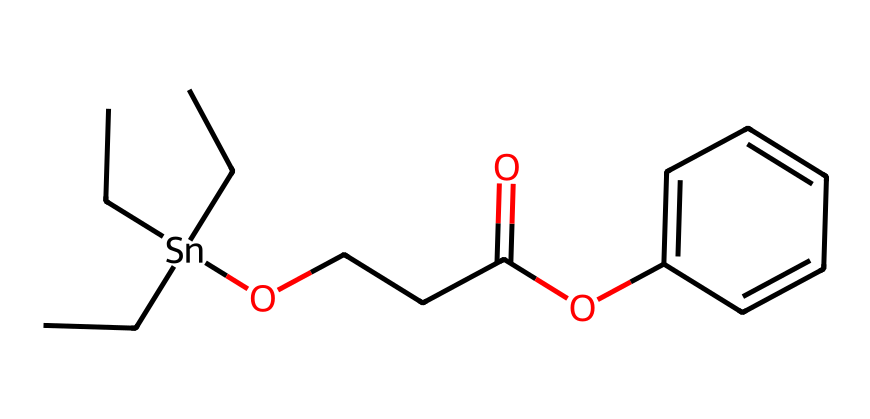What is the main metal present in this compound? The structure shows a tin atom connected to other carbon and oxygen atoms, which indicates that tin is the main metal component in this organometallic compound.
Answer: tin How many carbon atoms are present in this chemical? By counting the carbon atoms in the structure, including those in the alkyl groups and the aromatic ring, we find there are a total of 12 carbon atoms.
Answer: 12 What functional group is present in this compound that contributes to its weather resistance? The presence of an ester functional group (–COO–) in the chemical structure indicates that this compound can form protective layers, enhancing its weather resistance.
Answer: ester What is the connectivity of the tin atom in this structure? The tin atom (Sn) is coordinated to three carbon chains and one oxygen atom, forming a tetrahedral geometry where the atom is bonded to four different groups.
Answer: tetrahedral Which part of the molecule could potentially provide hydrophobic characteristics? The long carbon chains attached to the tin center are likely responsible for the hydrophobic characteristics, making the compound resistant to water and ideal for coatings.
Answer: long carbon chains How many oxygen atoms are present in this organotin compound? A careful count of the oxygen atoms in the structure shows there are two oxygen atoms due to the presence of the ester and hydroxyl groups.
Answer: 2 What makes this organotin compound suitable for coatings in varying weather conditions? The combination of the metal tin, the protective ester linkages, and the hydrophobic carbon chains equips this compound with both durability and stability, making it effective in various weather conditions.
Answer: stability 